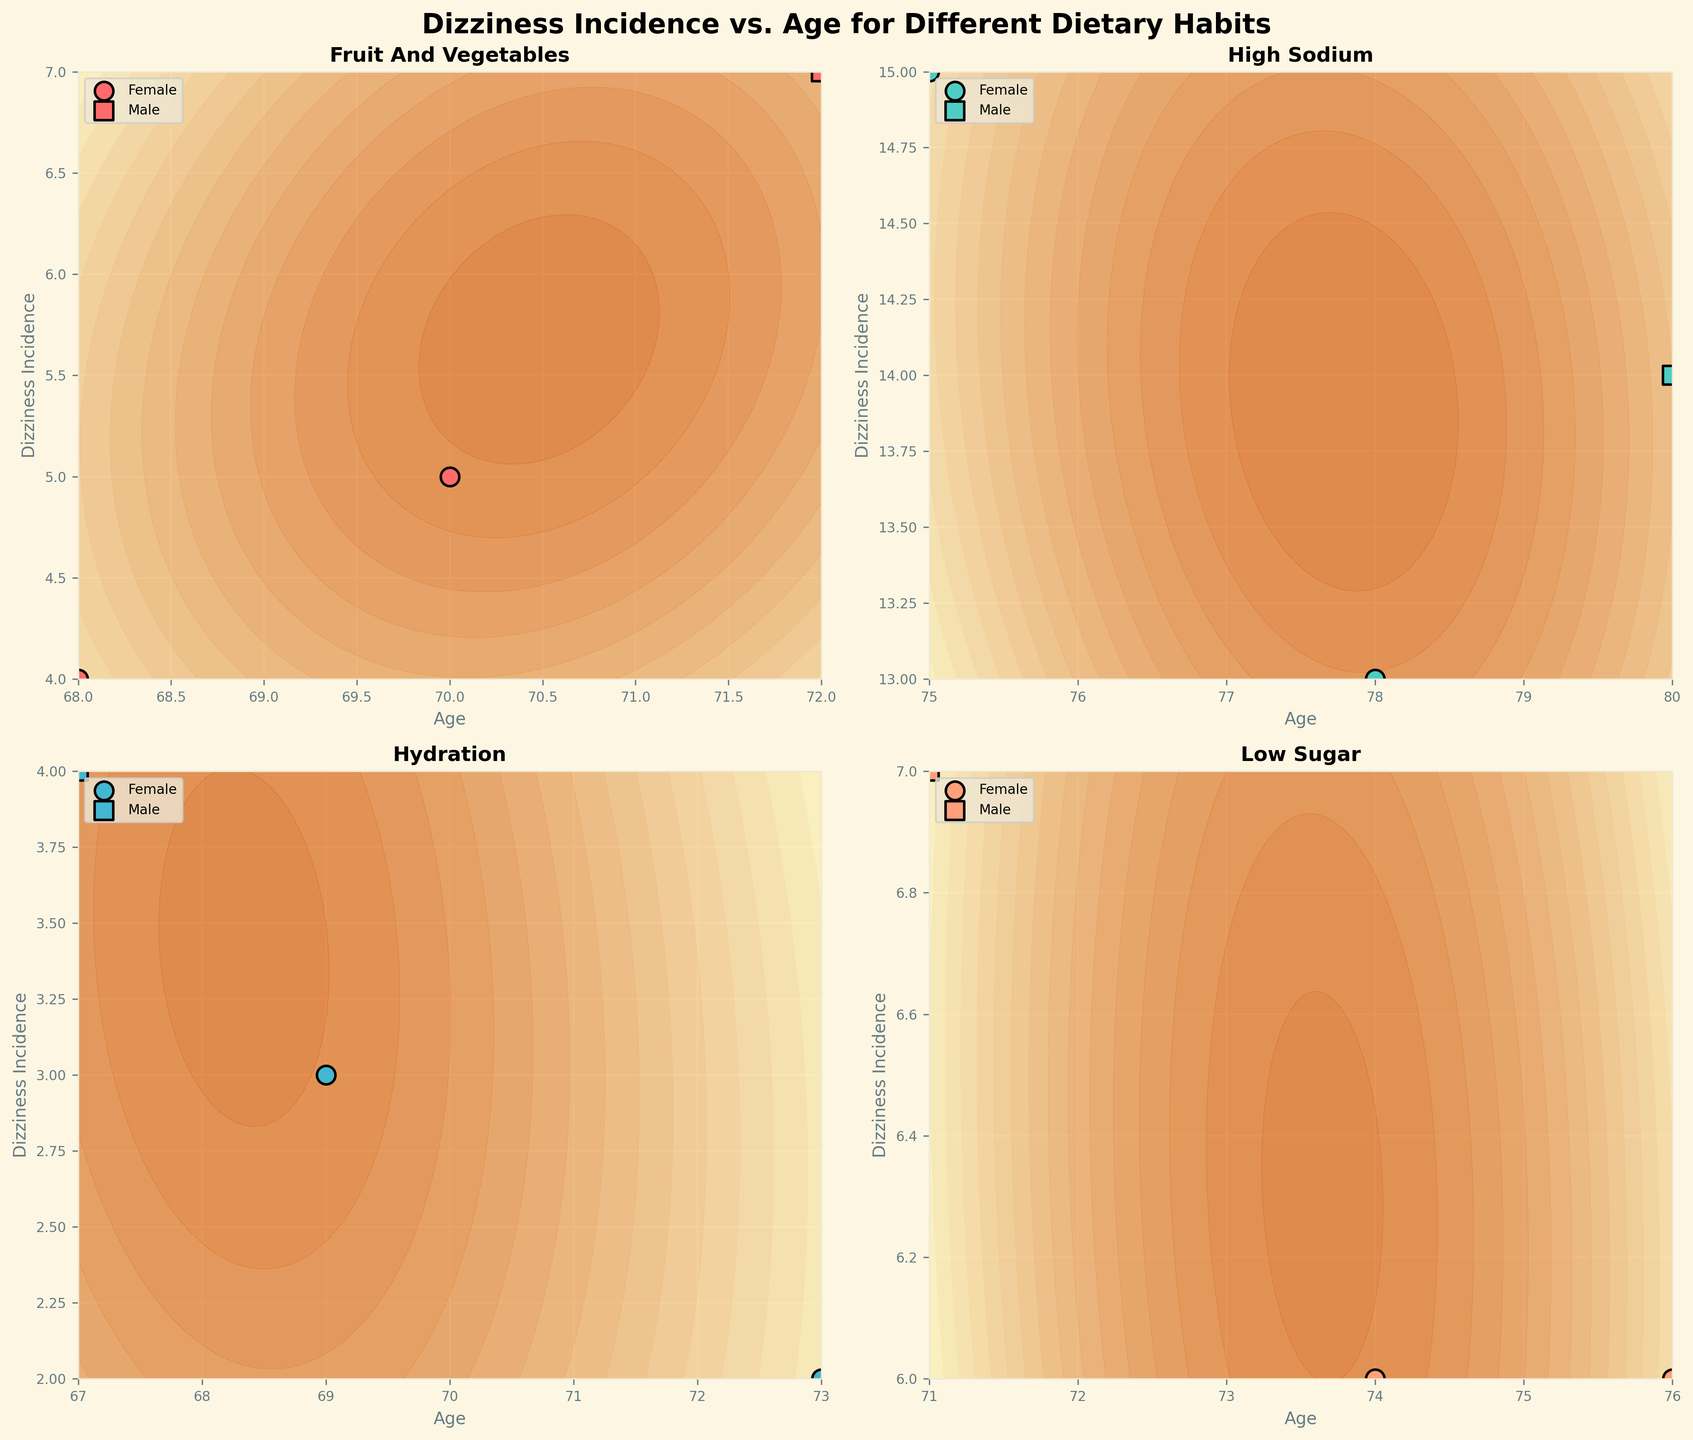What's the title of the figure? The title of the figure is displayed at the top center.
Answer: Dizziness Incidence vs. Age for Different Dietary Habits What information is displayed on the x-axis? The x-axis represents the age of individuals, which is labeled on all subplots.
Answer: Age How many dietary habits are featured in the subplots? There are four dietary habits shown in the subplots, one in each subplot.
Answer: Four Which dietary habit seems to have the highest overall dizziness incidence? By comparing the contour plots and data points in each subplot, the subplots for High Sodium consistently show the highest values on the y-axis, representing dizziness incidence.
Answer: High Sodium How does the dizziness incidence for Hydration compare to Low Sugar among the elderly? By inspecting both 'Hydration' and 'Low Sugar' subplots, the dizziness incidence for Hydration appears to be lower and more closely clustered around lower values than for Low Sugar.
Answer: Hydration has a lower dizziness incidence For the dietary habit 'Fruit and Vegetables', are there any significant gender differences in dizziness incidence? By observing the subplot for 'Fruit and Vegetables', there doesn't seem to be a significant difference in dizziness incidence between males and females since data points for both genders are intermingled and show similar values.
Answer: No significant gender differences Which dietary habit shows the most variation in dizziness incidence among the elderly? By analyzing the spread of the data points and contour plots, 'High Sodium' shows the widest variation in dizziness incidence.
Answer: High Sodium Is there any pattern observed between age and dizziness incidence in the 'Hydration' subplot? In the 'Hydration' subplot, there is a slight pattern where younger elderly have a slightly less dizziness incidence, but overall, the spread is quite narrow and not strongly correlated to age.
Answer: Slight pattern Between 'High Sodium' and 'Fruit and Vegetables', which one shows a broader age range of the participants? By comparing the x-axis spread in both subplots, 'High Sodium' shows a broader age range compared to 'Fruit and Vegetables'.
Answer: High Sodium Are data points for males and females evenly distributed across all subplots? Observing all subplots, both male and female data points are indeed evenly distributed without clear dominance by any single gender in any subplot.
Answer: Yes 